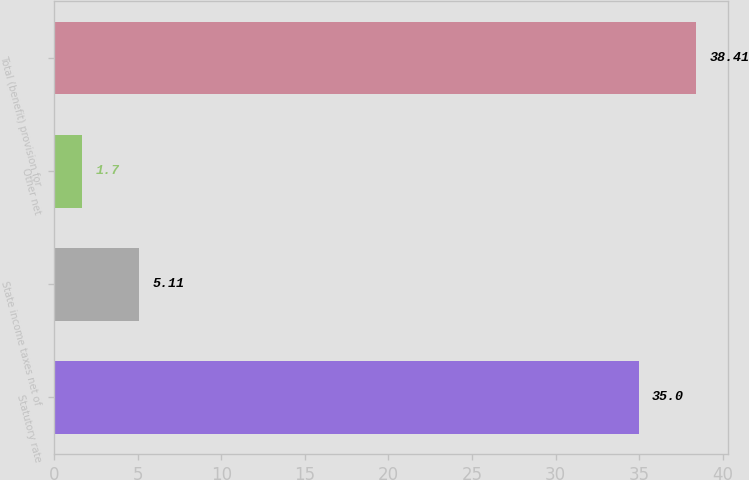Convert chart to OTSL. <chart><loc_0><loc_0><loc_500><loc_500><bar_chart><fcel>Statutory rate<fcel>State income taxes net of<fcel>Other net<fcel>Total (benefit) provision for<nl><fcel>35<fcel>5.11<fcel>1.7<fcel>38.41<nl></chart> 